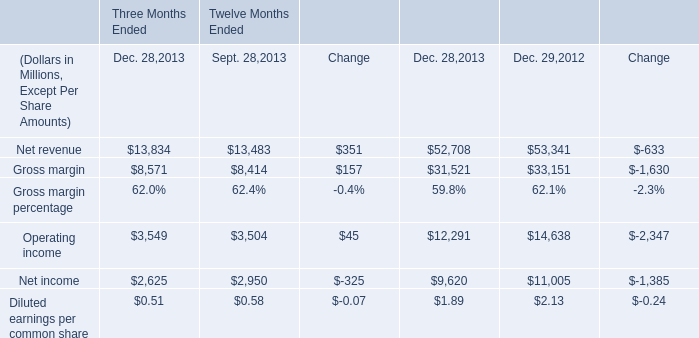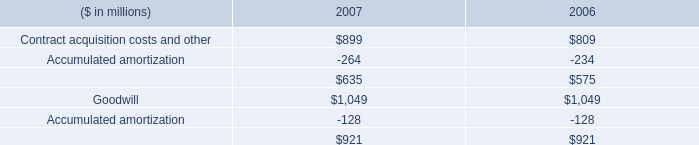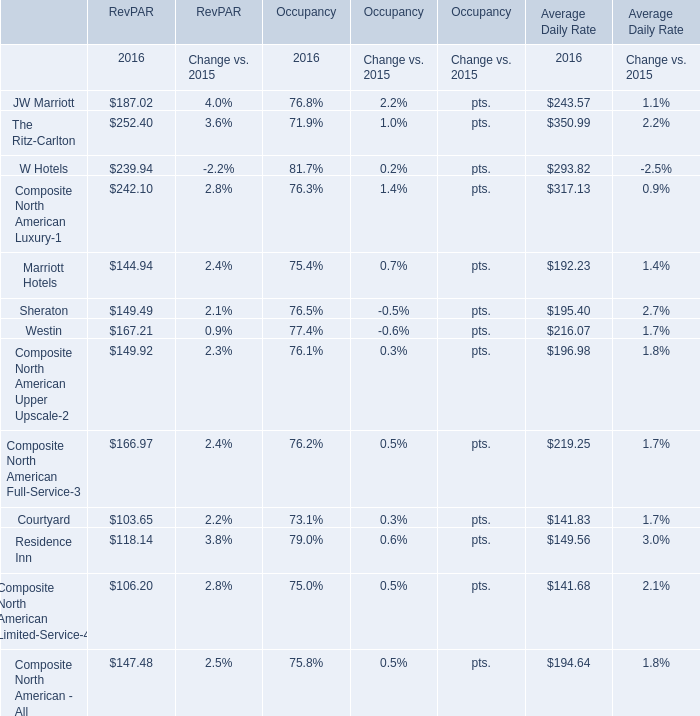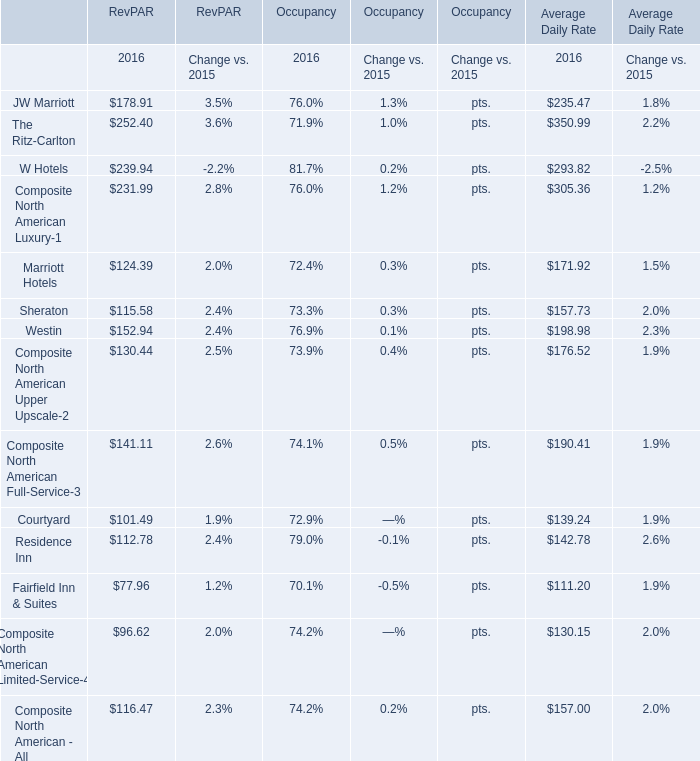What's the growth rate of JW Marriott for RevPAR in 2016? 
Answer: 0.04. If JW Marriott for RevPAR develops with the same growth rate in 2016, what will it reach in 2017? 
Computations: (187.02 * (1 + 0.04))
Answer: 194.5008. 